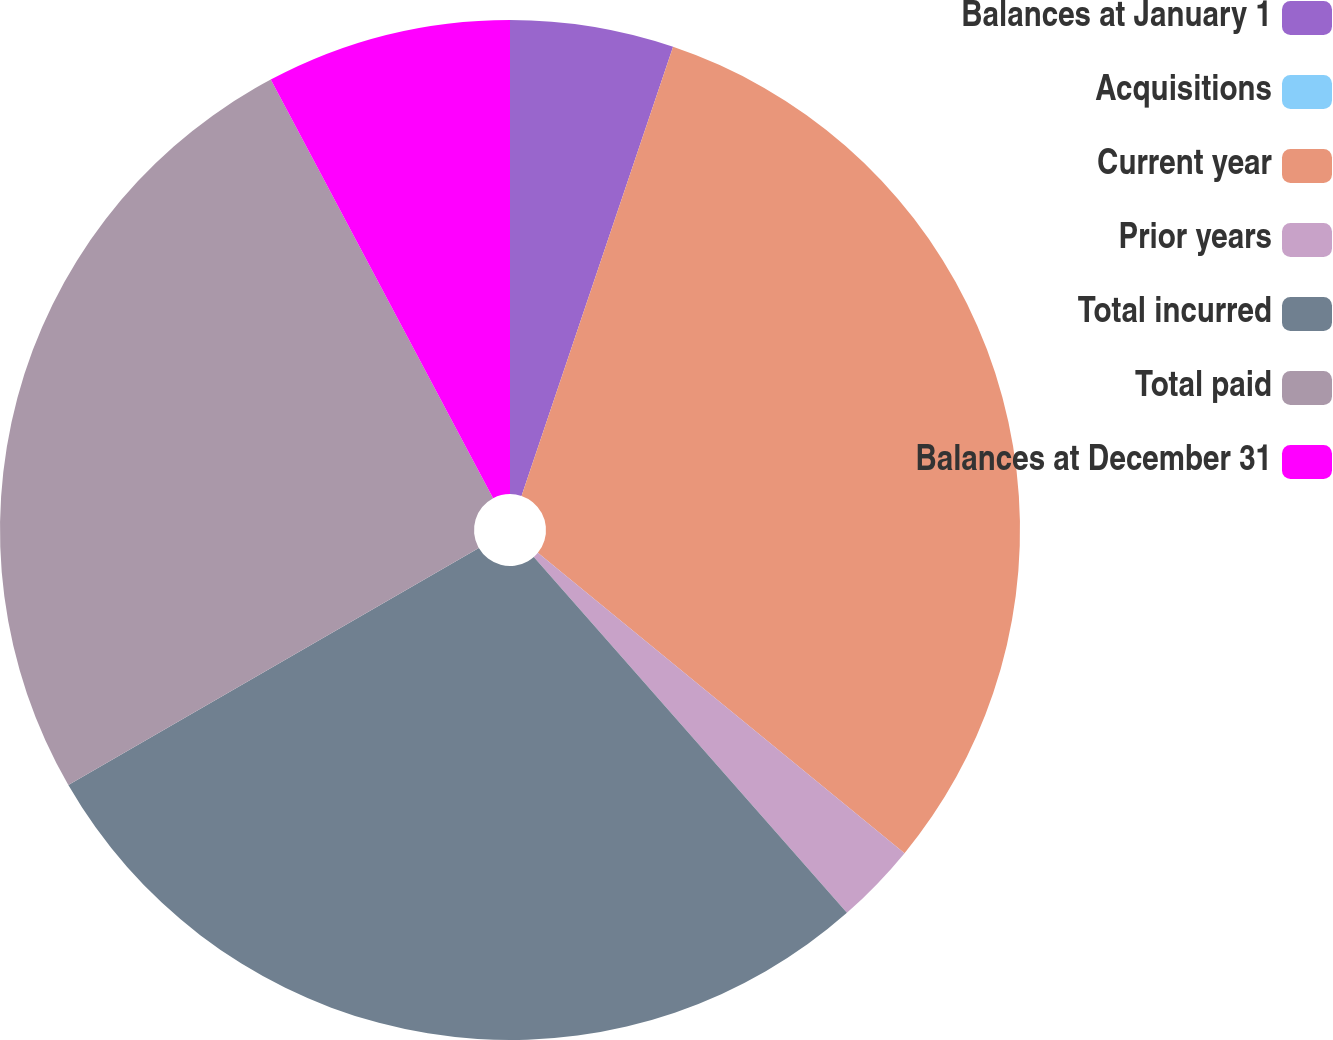Convert chart. <chart><loc_0><loc_0><loc_500><loc_500><pie_chart><fcel>Balances at January 1<fcel>Acquisitions<fcel>Current year<fcel>Prior years<fcel>Total incurred<fcel>Total paid<fcel>Balances at December 31<nl><fcel>5.18%<fcel>0.0%<fcel>30.74%<fcel>2.59%<fcel>28.15%<fcel>25.56%<fcel>7.77%<nl></chart> 